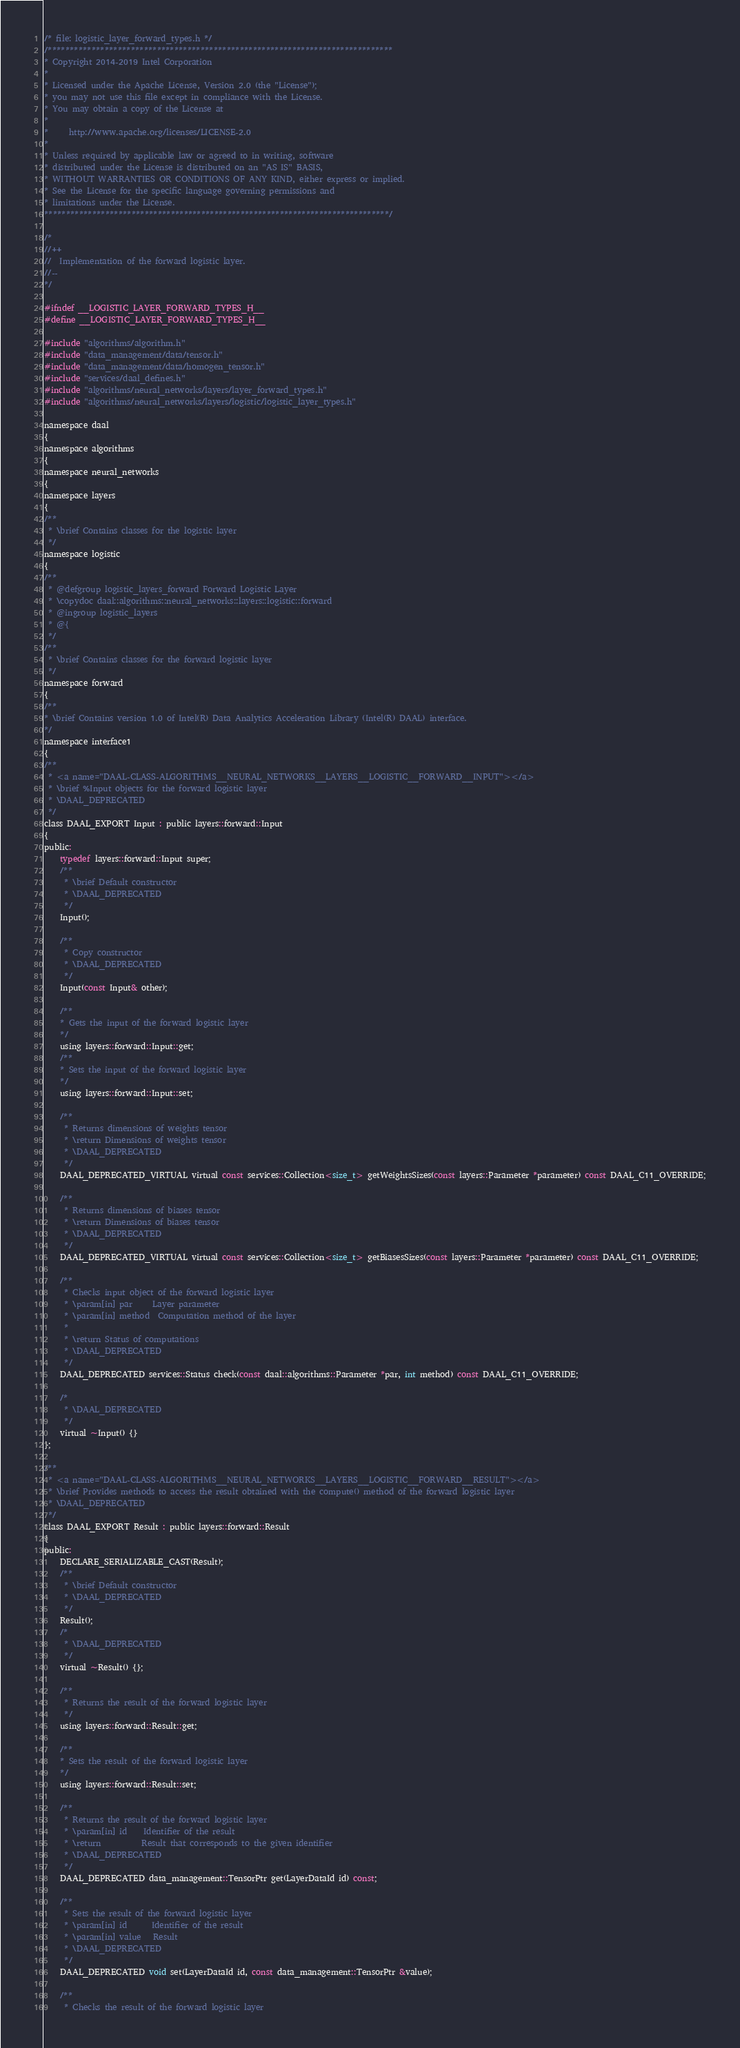Convert code to text. <code><loc_0><loc_0><loc_500><loc_500><_C_>/* file: logistic_layer_forward_types.h */
/*******************************************************************************
* Copyright 2014-2019 Intel Corporation
*
* Licensed under the Apache License, Version 2.0 (the "License");
* you may not use this file except in compliance with the License.
* You may obtain a copy of the License at
*
*     http://www.apache.org/licenses/LICENSE-2.0
*
* Unless required by applicable law or agreed to in writing, software
* distributed under the License is distributed on an "AS IS" BASIS,
* WITHOUT WARRANTIES OR CONDITIONS OF ANY KIND, either express or implied.
* See the License for the specific language governing permissions and
* limitations under the License.
*******************************************************************************/

/*
//++
//  Implementation of the forward logistic layer.
//--
*/

#ifndef __LOGISTIC_LAYER_FORWARD_TYPES_H__
#define __LOGISTIC_LAYER_FORWARD_TYPES_H__

#include "algorithms/algorithm.h"
#include "data_management/data/tensor.h"
#include "data_management/data/homogen_tensor.h"
#include "services/daal_defines.h"
#include "algorithms/neural_networks/layers/layer_forward_types.h"
#include "algorithms/neural_networks/layers/logistic/logistic_layer_types.h"

namespace daal
{
namespace algorithms
{
namespace neural_networks
{
namespace layers
{
/**
 * \brief Contains classes for the logistic layer
 */
namespace logistic
{
/**
 * @defgroup logistic_layers_forward Forward Logistic Layer
 * \copydoc daal::algorithms::neural_networks::layers::logistic::forward
 * @ingroup logistic_layers
 * @{
 */
/**
 * \brief Contains classes for the forward logistic layer
 */
namespace forward
{
/**
* \brief Contains version 1.0 of Intel(R) Data Analytics Acceleration Library (Intel(R) DAAL) interface.
*/
namespace interface1
{
/**
 * <a name="DAAL-CLASS-ALGORITHMS__NEURAL_NETWORKS__LAYERS__LOGISTIC__FORWARD__INPUT"></a>
 * \brief %Input objects for the forward logistic layer
 * \DAAL_DEPRECATED
 */
class DAAL_EXPORT Input : public layers::forward::Input
{
public:
    typedef layers::forward::Input super;
    /**
     * \brief Default constructor
     * \DAAL_DEPRECATED
     */
    Input();

    /**
     * Copy constructor
     * \DAAL_DEPRECATED
     */
    Input(const Input& other);

    /**
    * Gets the input of the forward logistic layer
    */
    using layers::forward::Input::get;
    /**
    * Sets the input of the forward logistic layer
    */
    using layers::forward::Input::set;

    /**
     * Returns dimensions of weights tensor
     * \return Dimensions of weights tensor
     * \DAAL_DEPRECATED
     */
    DAAL_DEPRECATED_VIRTUAL virtual const services::Collection<size_t> getWeightsSizes(const layers::Parameter *parameter) const DAAL_C11_OVERRIDE;

    /**
     * Returns dimensions of biases tensor
     * \return Dimensions of biases tensor
     * \DAAL_DEPRECATED
     */
    DAAL_DEPRECATED_VIRTUAL virtual const services::Collection<size_t> getBiasesSizes(const layers::Parameter *parameter) const DAAL_C11_OVERRIDE;

    /**
     * Checks input object of the forward logistic layer
     * \param[in] par     Layer parameter
     * \param[in] method  Computation method of the layer
     *
     * \return Status of computations
     * \DAAL_DEPRECATED
     */
    DAAL_DEPRECATED services::Status check(const daal::algorithms::Parameter *par, int method) const DAAL_C11_OVERRIDE;

    /*
     * \DAAL_DEPRECATED
     */
    virtual ~Input() {}
};

/**
 * <a name="DAAL-CLASS-ALGORITHMS__NEURAL_NETWORKS__LAYERS__LOGISTIC__FORWARD__RESULT"></a>
 * \brief Provides methods to access the result obtained with the compute() method of the forward logistic layer
 * \DAAL_DEPRECATED
 */
class DAAL_EXPORT Result : public layers::forward::Result
{
public:
    DECLARE_SERIALIZABLE_CAST(Result);
    /**
     * \brief Default constructor
     * \DAAL_DEPRECATED
     */
    Result();
    /*
     * \DAAL_DEPRECATED
     */
    virtual ~Result() {};

    /**
     * Returns the result of the forward logistic layer
     */
    using layers::forward::Result::get;

    /**
    * Sets the result of the forward logistic layer
    */
    using layers::forward::Result::set;

    /**
     * Returns the result of the forward logistic layer
     * \param[in] id    Identifier of the result
     * \return          Result that corresponds to the given identifier
     * \DAAL_DEPRECATED
     */
    DAAL_DEPRECATED data_management::TensorPtr get(LayerDataId id) const;

    /**
     * Sets the result of the forward logistic layer
     * \param[in] id      Identifier of the result
     * \param[in] value   Result
     * \DAAL_DEPRECATED
     */
    DAAL_DEPRECATED void set(LayerDataId id, const data_management::TensorPtr &value);

    /**
     * Checks the result of the forward logistic layer</code> 